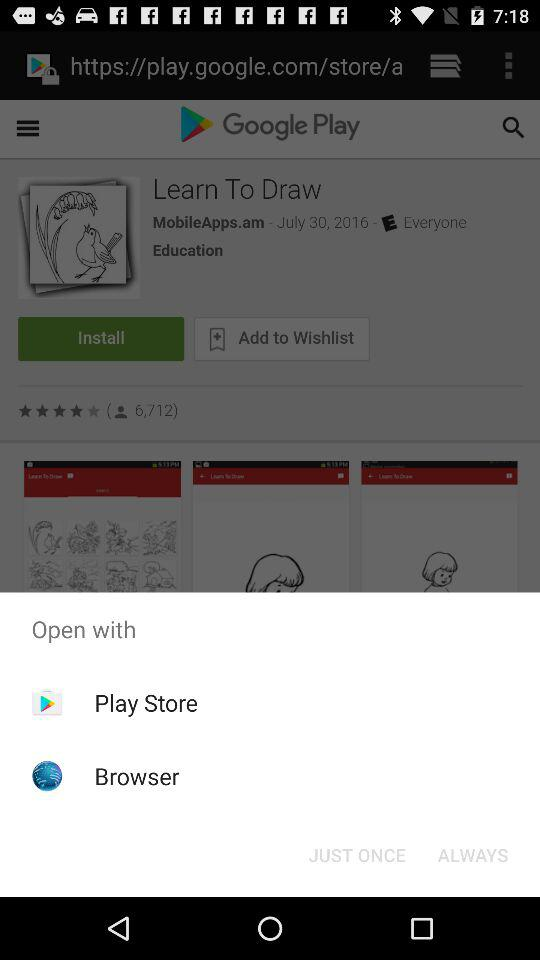What are the options to open? The options to open are "Play Store" and "Browser". 